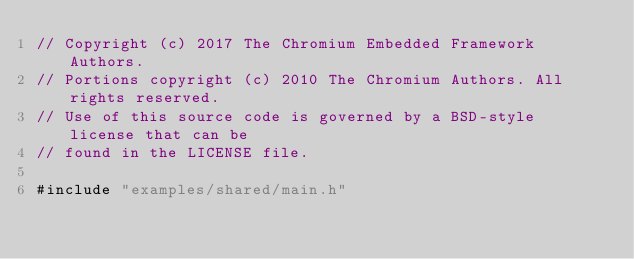<code> <loc_0><loc_0><loc_500><loc_500><_ObjectiveC_>// Copyright (c) 2017 The Chromium Embedded Framework Authors.
// Portions copyright (c) 2010 The Chromium Authors. All rights reserved.
// Use of this source code is governed by a BSD-style license that can be
// found in the LICENSE file.

#include "examples/shared/main.h"
</code> 